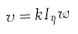<formula> <loc_0><loc_0><loc_500><loc_500>v = k I _ { \eta } w</formula> 